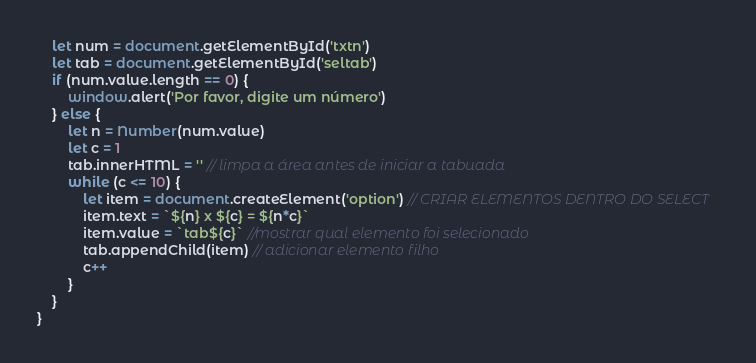<code> <loc_0><loc_0><loc_500><loc_500><_JavaScript_>    let num = document.getElementById('txtn')
    let tab = document.getElementById('seltab')
    if (num.value.length == 0) {
        window.alert('Por favor, digite um número')
    } else {
        let n = Number(num.value)
        let c = 1
        tab.innerHTML = '' // limpa a área antes de iniciar a tabuada
        while (c <= 10) {
            let item = document.createElement('option') // CRIAR ELEMENTOS DENTRO DO SELECT
            item.text = `${n} x ${c} = ${n*c}`
            item.value = `tab${c}` //mostrar qual elemento foi selecionado
            tab.appendChild(item) // adicionar elemento filho
            c++
        }
    }
}</code> 